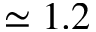<formula> <loc_0><loc_0><loc_500><loc_500>\simeq 1 . 2</formula> 